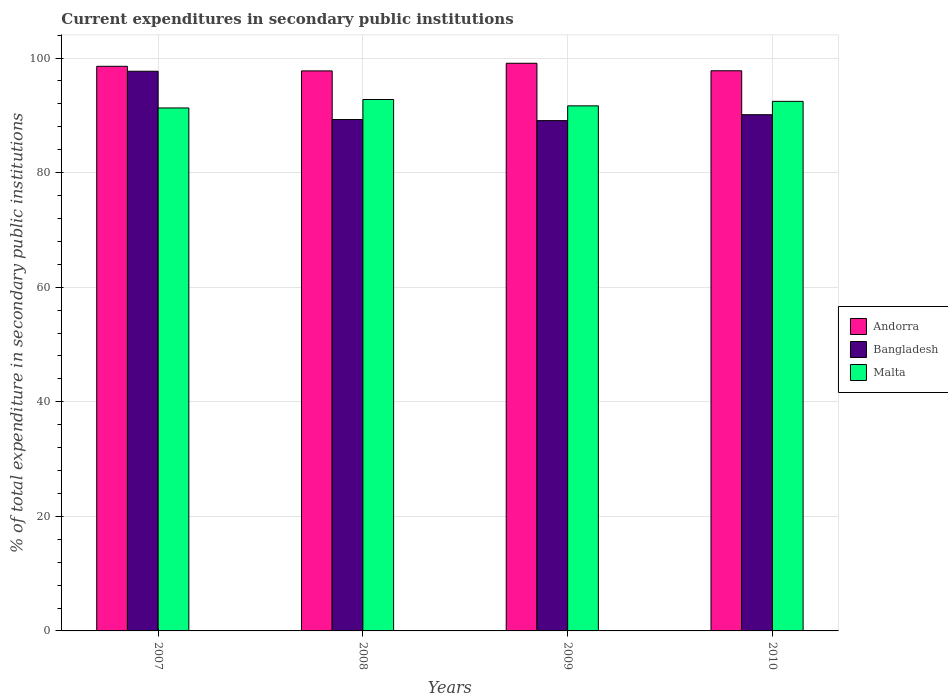Are the number of bars per tick equal to the number of legend labels?
Keep it short and to the point. Yes. In how many cases, is the number of bars for a given year not equal to the number of legend labels?
Keep it short and to the point. 0. What is the current expenditures in secondary public institutions in Andorra in 2007?
Provide a succinct answer. 98.56. Across all years, what is the maximum current expenditures in secondary public institutions in Malta?
Offer a terse response. 92.76. Across all years, what is the minimum current expenditures in secondary public institutions in Malta?
Ensure brevity in your answer.  91.29. In which year was the current expenditures in secondary public institutions in Malta maximum?
Make the answer very short. 2008. In which year was the current expenditures in secondary public institutions in Andorra minimum?
Ensure brevity in your answer.  2008. What is the total current expenditures in secondary public institutions in Bangladesh in the graph?
Offer a terse response. 366.15. What is the difference between the current expenditures in secondary public institutions in Bangladesh in 2008 and that in 2010?
Offer a terse response. -0.84. What is the difference between the current expenditures in secondary public institutions in Andorra in 2007 and the current expenditures in secondary public institutions in Bangladesh in 2010?
Provide a short and direct response. 8.45. What is the average current expenditures in secondary public institutions in Bangladesh per year?
Offer a terse response. 91.54. In the year 2007, what is the difference between the current expenditures in secondary public institutions in Andorra and current expenditures in secondary public institutions in Malta?
Your answer should be compact. 7.27. What is the ratio of the current expenditures in secondary public institutions in Andorra in 2007 to that in 2008?
Your answer should be very brief. 1.01. Is the current expenditures in secondary public institutions in Malta in 2007 less than that in 2010?
Offer a very short reply. Yes. Is the difference between the current expenditures in secondary public institutions in Andorra in 2008 and 2010 greater than the difference between the current expenditures in secondary public institutions in Malta in 2008 and 2010?
Keep it short and to the point. No. What is the difference between the highest and the second highest current expenditures in secondary public institutions in Andorra?
Provide a short and direct response. 0.53. What is the difference between the highest and the lowest current expenditures in secondary public institutions in Andorra?
Your response must be concise. 1.33. What does the 3rd bar from the right in 2008 represents?
Your response must be concise. Andorra. How many bars are there?
Give a very brief answer. 12. What is the difference between two consecutive major ticks on the Y-axis?
Provide a succinct answer. 20. Are the values on the major ticks of Y-axis written in scientific E-notation?
Provide a succinct answer. No. Where does the legend appear in the graph?
Make the answer very short. Center right. How many legend labels are there?
Your response must be concise. 3. What is the title of the graph?
Your response must be concise. Current expenditures in secondary public institutions. Does "Greece" appear as one of the legend labels in the graph?
Offer a terse response. No. What is the label or title of the X-axis?
Offer a very short reply. Years. What is the label or title of the Y-axis?
Provide a succinct answer. % of total expenditure in secondary public institutions. What is the % of total expenditure in secondary public institutions in Andorra in 2007?
Your answer should be very brief. 98.56. What is the % of total expenditure in secondary public institutions in Bangladesh in 2007?
Ensure brevity in your answer.  97.69. What is the % of total expenditure in secondary public institutions in Malta in 2007?
Your answer should be compact. 91.29. What is the % of total expenditure in secondary public institutions in Andorra in 2008?
Ensure brevity in your answer.  97.76. What is the % of total expenditure in secondary public institutions of Bangladesh in 2008?
Offer a very short reply. 89.26. What is the % of total expenditure in secondary public institutions in Malta in 2008?
Provide a succinct answer. 92.76. What is the % of total expenditure in secondary public institutions in Andorra in 2009?
Provide a succinct answer. 99.09. What is the % of total expenditure in secondary public institutions in Bangladesh in 2009?
Make the answer very short. 89.08. What is the % of total expenditure in secondary public institutions of Malta in 2009?
Your answer should be compact. 91.65. What is the % of total expenditure in secondary public institutions of Andorra in 2010?
Make the answer very short. 97.78. What is the % of total expenditure in secondary public institutions in Bangladesh in 2010?
Your answer should be compact. 90.11. What is the % of total expenditure in secondary public institutions of Malta in 2010?
Provide a succinct answer. 92.44. Across all years, what is the maximum % of total expenditure in secondary public institutions in Andorra?
Provide a succinct answer. 99.09. Across all years, what is the maximum % of total expenditure in secondary public institutions in Bangladesh?
Your answer should be very brief. 97.69. Across all years, what is the maximum % of total expenditure in secondary public institutions in Malta?
Offer a very short reply. 92.76. Across all years, what is the minimum % of total expenditure in secondary public institutions in Andorra?
Provide a succinct answer. 97.76. Across all years, what is the minimum % of total expenditure in secondary public institutions of Bangladesh?
Give a very brief answer. 89.08. Across all years, what is the minimum % of total expenditure in secondary public institutions in Malta?
Provide a succinct answer. 91.29. What is the total % of total expenditure in secondary public institutions in Andorra in the graph?
Offer a very short reply. 393.18. What is the total % of total expenditure in secondary public institutions of Bangladesh in the graph?
Your answer should be very brief. 366.15. What is the total % of total expenditure in secondary public institutions of Malta in the graph?
Give a very brief answer. 368.14. What is the difference between the % of total expenditure in secondary public institutions of Andorra in 2007 and that in 2008?
Provide a short and direct response. 0.8. What is the difference between the % of total expenditure in secondary public institutions in Bangladesh in 2007 and that in 2008?
Ensure brevity in your answer.  8.43. What is the difference between the % of total expenditure in secondary public institutions of Malta in 2007 and that in 2008?
Provide a short and direct response. -1.48. What is the difference between the % of total expenditure in secondary public institutions of Andorra in 2007 and that in 2009?
Keep it short and to the point. -0.53. What is the difference between the % of total expenditure in secondary public institutions in Bangladesh in 2007 and that in 2009?
Your response must be concise. 8.62. What is the difference between the % of total expenditure in secondary public institutions in Malta in 2007 and that in 2009?
Keep it short and to the point. -0.37. What is the difference between the % of total expenditure in secondary public institutions of Andorra in 2007 and that in 2010?
Provide a short and direct response. 0.78. What is the difference between the % of total expenditure in secondary public institutions in Bangladesh in 2007 and that in 2010?
Make the answer very short. 7.58. What is the difference between the % of total expenditure in secondary public institutions of Malta in 2007 and that in 2010?
Ensure brevity in your answer.  -1.15. What is the difference between the % of total expenditure in secondary public institutions in Andorra in 2008 and that in 2009?
Your answer should be very brief. -1.33. What is the difference between the % of total expenditure in secondary public institutions in Bangladesh in 2008 and that in 2009?
Your answer should be very brief. 0.19. What is the difference between the % of total expenditure in secondary public institutions of Malta in 2008 and that in 2009?
Provide a succinct answer. 1.11. What is the difference between the % of total expenditure in secondary public institutions of Andorra in 2008 and that in 2010?
Give a very brief answer. -0.02. What is the difference between the % of total expenditure in secondary public institutions in Bangladesh in 2008 and that in 2010?
Provide a short and direct response. -0.84. What is the difference between the % of total expenditure in secondary public institutions in Malta in 2008 and that in 2010?
Your answer should be compact. 0.32. What is the difference between the % of total expenditure in secondary public institutions in Andorra in 2009 and that in 2010?
Offer a terse response. 1.31. What is the difference between the % of total expenditure in secondary public institutions of Bangladesh in 2009 and that in 2010?
Offer a very short reply. -1.03. What is the difference between the % of total expenditure in secondary public institutions in Malta in 2009 and that in 2010?
Give a very brief answer. -0.79. What is the difference between the % of total expenditure in secondary public institutions in Andorra in 2007 and the % of total expenditure in secondary public institutions in Bangladesh in 2008?
Provide a succinct answer. 9.29. What is the difference between the % of total expenditure in secondary public institutions in Andorra in 2007 and the % of total expenditure in secondary public institutions in Malta in 2008?
Provide a succinct answer. 5.79. What is the difference between the % of total expenditure in secondary public institutions of Bangladesh in 2007 and the % of total expenditure in secondary public institutions of Malta in 2008?
Offer a terse response. 4.93. What is the difference between the % of total expenditure in secondary public institutions of Andorra in 2007 and the % of total expenditure in secondary public institutions of Bangladesh in 2009?
Make the answer very short. 9.48. What is the difference between the % of total expenditure in secondary public institutions in Andorra in 2007 and the % of total expenditure in secondary public institutions in Malta in 2009?
Provide a short and direct response. 6.9. What is the difference between the % of total expenditure in secondary public institutions of Bangladesh in 2007 and the % of total expenditure in secondary public institutions of Malta in 2009?
Your response must be concise. 6.04. What is the difference between the % of total expenditure in secondary public institutions of Andorra in 2007 and the % of total expenditure in secondary public institutions of Bangladesh in 2010?
Ensure brevity in your answer.  8.45. What is the difference between the % of total expenditure in secondary public institutions in Andorra in 2007 and the % of total expenditure in secondary public institutions in Malta in 2010?
Offer a very short reply. 6.12. What is the difference between the % of total expenditure in secondary public institutions of Bangladesh in 2007 and the % of total expenditure in secondary public institutions of Malta in 2010?
Provide a succinct answer. 5.25. What is the difference between the % of total expenditure in secondary public institutions of Andorra in 2008 and the % of total expenditure in secondary public institutions of Bangladesh in 2009?
Provide a succinct answer. 8.68. What is the difference between the % of total expenditure in secondary public institutions of Andorra in 2008 and the % of total expenditure in secondary public institutions of Malta in 2009?
Offer a very short reply. 6.1. What is the difference between the % of total expenditure in secondary public institutions of Bangladesh in 2008 and the % of total expenditure in secondary public institutions of Malta in 2009?
Provide a short and direct response. -2.39. What is the difference between the % of total expenditure in secondary public institutions of Andorra in 2008 and the % of total expenditure in secondary public institutions of Bangladesh in 2010?
Offer a terse response. 7.65. What is the difference between the % of total expenditure in secondary public institutions in Andorra in 2008 and the % of total expenditure in secondary public institutions in Malta in 2010?
Offer a terse response. 5.32. What is the difference between the % of total expenditure in secondary public institutions of Bangladesh in 2008 and the % of total expenditure in secondary public institutions of Malta in 2010?
Provide a succinct answer. -3.18. What is the difference between the % of total expenditure in secondary public institutions in Andorra in 2009 and the % of total expenditure in secondary public institutions in Bangladesh in 2010?
Make the answer very short. 8.98. What is the difference between the % of total expenditure in secondary public institutions of Andorra in 2009 and the % of total expenditure in secondary public institutions of Malta in 2010?
Give a very brief answer. 6.65. What is the difference between the % of total expenditure in secondary public institutions of Bangladesh in 2009 and the % of total expenditure in secondary public institutions of Malta in 2010?
Keep it short and to the point. -3.36. What is the average % of total expenditure in secondary public institutions in Andorra per year?
Ensure brevity in your answer.  98.29. What is the average % of total expenditure in secondary public institutions of Bangladesh per year?
Give a very brief answer. 91.54. What is the average % of total expenditure in secondary public institutions of Malta per year?
Keep it short and to the point. 92.04. In the year 2007, what is the difference between the % of total expenditure in secondary public institutions of Andorra and % of total expenditure in secondary public institutions of Bangladesh?
Ensure brevity in your answer.  0.86. In the year 2007, what is the difference between the % of total expenditure in secondary public institutions of Andorra and % of total expenditure in secondary public institutions of Malta?
Offer a terse response. 7.27. In the year 2007, what is the difference between the % of total expenditure in secondary public institutions in Bangladesh and % of total expenditure in secondary public institutions in Malta?
Your response must be concise. 6.41. In the year 2008, what is the difference between the % of total expenditure in secondary public institutions in Andorra and % of total expenditure in secondary public institutions in Bangladesh?
Make the answer very short. 8.49. In the year 2008, what is the difference between the % of total expenditure in secondary public institutions in Andorra and % of total expenditure in secondary public institutions in Malta?
Your answer should be very brief. 4.99. In the year 2008, what is the difference between the % of total expenditure in secondary public institutions in Bangladesh and % of total expenditure in secondary public institutions in Malta?
Your response must be concise. -3.5. In the year 2009, what is the difference between the % of total expenditure in secondary public institutions in Andorra and % of total expenditure in secondary public institutions in Bangladesh?
Provide a short and direct response. 10.01. In the year 2009, what is the difference between the % of total expenditure in secondary public institutions of Andorra and % of total expenditure in secondary public institutions of Malta?
Ensure brevity in your answer.  7.44. In the year 2009, what is the difference between the % of total expenditure in secondary public institutions of Bangladesh and % of total expenditure in secondary public institutions of Malta?
Your answer should be very brief. -2.58. In the year 2010, what is the difference between the % of total expenditure in secondary public institutions in Andorra and % of total expenditure in secondary public institutions in Bangladesh?
Give a very brief answer. 7.67. In the year 2010, what is the difference between the % of total expenditure in secondary public institutions of Andorra and % of total expenditure in secondary public institutions of Malta?
Your answer should be very brief. 5.34. In the year 2010, what is the difference between the % of total expenditure in secondary public institutions of Bangladesh and % of total expenditure in secondary public institutions of Malta?
Provide a succinct answer. -2.33. What is the ratio of the % of total expenditure in secondary public institutions of Andorra in 2007 to that in 2008?
Give a very brief answer. 1.01. What is the ratio of the % of total expenditure in secondary public institutions in Bangladesh in 2007 to that in 2008?
Give a very brief answer. 1.09. What is the ratio of the % of total expenditure in secondary public institutions of Malta in 2007 to that in 2008?
Provide a short and direct response. 0.98. What is the ratio of the % of total expenditure in secondary public institutions in Andorra in 2007 to that in 2009?
Your answer should be compact. 0.99. What is the ratio of the % of total expenditure in secondary public institutions in Bangladesh in 2007 to that in 2009?
Make the answer very short. 1.1. What is the ratio of the % of total expenditure in secondary public institutions of Malta in 2007 to that in 2009?
Provide a short and direct response. 1. What is the ratio of the % of total expenditure in secondary public institutions of Bangladesh in 2007 to that in 2010?
Make the answer very short. 1.08. What is the ratio of the % of total expenditure in secondary public institutions of Malta in 2007 to that in 2010?
Provide a short and direct response. 0.99. What is the ratio of the % of total expenditure in secondary public institutions in Andorra in 2008 to that in 2009?
Provide a succinct answer. 0.99. What is the ratio of the % of total expenditure in secondary public institutions in Bangladesh in 2008 to that in 2009?
Give a very brief answer. 1. What is the ratio of the % of total expenditure in secondary public institutions in Malta in 2008 to that in 2009?
Your answer should be very brief. 1.01. What is the ratio of the % of total expenditure in secondary public institutions of Bangladesh in 2008 to that in 2010?
Make the answer very short. 0.99. What is the ratio of the % of total expenditure in secondary public institutions of Malta in 2008 to that in 2010?
Ensure brevity in your answer.  1. What is the ratio of the % of total expenditure in secondary public institutions in Andorra in 2009 to that in 2010?
Your answer should be very brief. 1.01. What is the ratio of the % of total expenditure in secondary public institutions in Malta in 2009 to that in 2010?
Make the answer very short. 0.99. What is the difference between the highest and the second highest % of total expenditure in secondary public institutions of Andorra?
Provide a succinct answer. 0.53. What is the difference between the highest and the second highest % of total expenditure in secondary public institutions in Bangladesh?
Provide a succinct answer. 7.58. What is the difference between the highest and the second highest % of total expenditure in secondary public institutions of Malta?
Offer a very short reply. 0.32. What is the difference between the highest and the lowest % of total expenditure in secondary public institutions of Andorra?
Your answer should be very brief. 1.33. What is the difference between the highest and the lowest % of total expenditure in secondary public institutions of Bangladesh?
Your answer should be compact. 8.62. What is the difference between the highest and the lowest % of total expenditure in secondary public institutions in Malta?
Give a very brief answer. 1.48. 